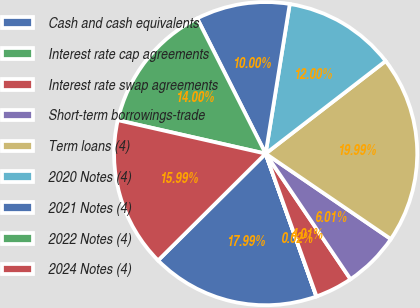Convert chart. <chart><loc_0><loc_0><loc_500><loc_500><pie_chart><fcel>Cash and cash equivalents<fcel>Interest rate cap agreements<fcel>Interest rate swap agreements<fcel>Short-term borrowings-trade<fcel>Term loans (4)<fcel>2020 Notes (4)<fcel>2021 Notes (4)<fcel>2022 Notes (4)<fcel>2024 Notes (4)<nl><fcel>17.99%<fcel>0.02%<fcel>4.01%<fcel>6.01%<fcel>19.99%<fcel>12.0%<fcel>10.0%<fcel>14.0%<fcel>15.99%<nl></chart> 